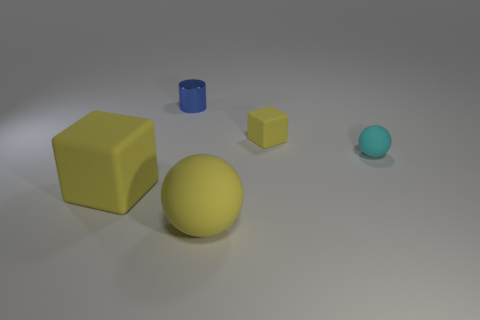Compare the sizes of the objects. Can you give an estimation? Certainly. The largest object appears to be the yellow sphere, followed by the yellow cube which seems to be a bit smaller in volume. The blue cylinder is significantly smaller than both the yellow cube and sphere. Finally, the smallest object is the turquoise sphere, which is smaller than all the other objects. Exact estimations of size cannot be determined without a reference, but the differences in scale among the objects are clearly observable. 